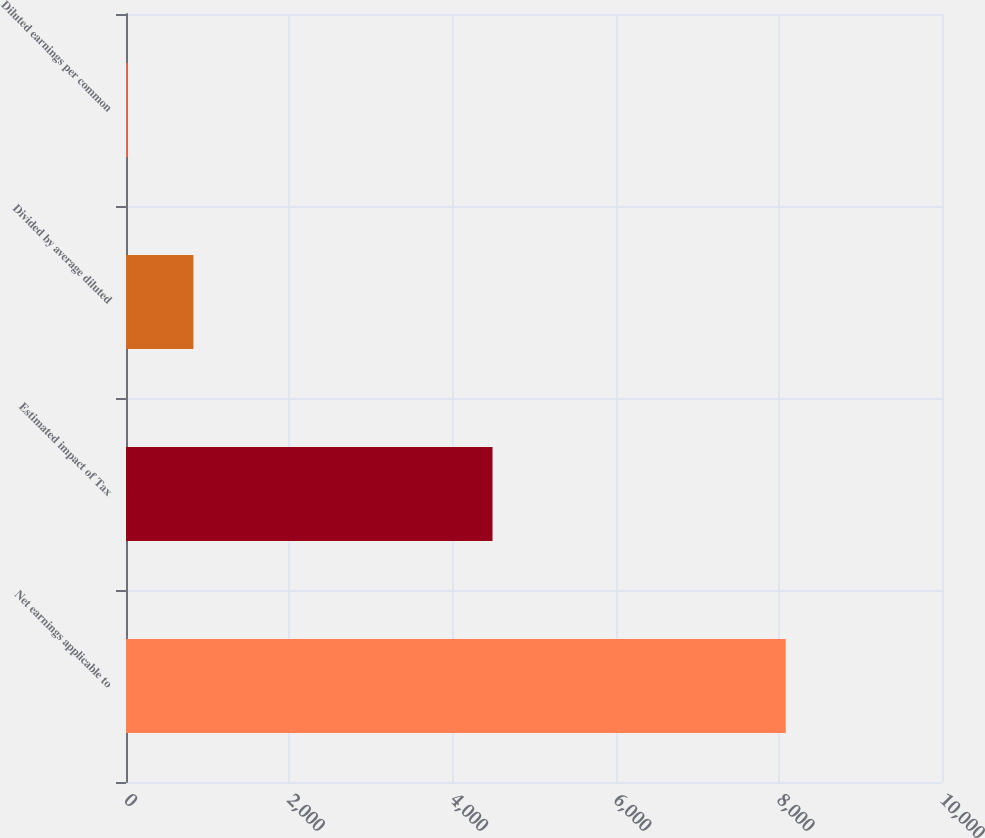Convert chart. <chart><loc_0><loc_0><loc_500><loc_500><bar_chart><fcel>Net earnings applicable to<fcel>Estimated impact of Tax<fcel>Divided by average diluted<fcel>Diluted earnings per common<nl><fcel>8085<fcel>4491.52<fcel>826.28<fcel>19.76<nl></chart> 